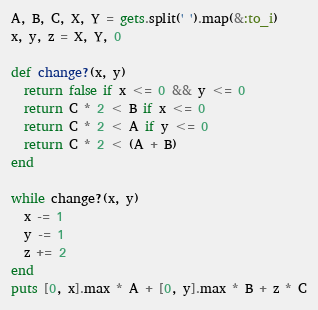Convert code to text. <code><loc_0><loc_0><loc_500><loc_500><_Ruby_>A, B, C, X, Y = gets.split(' ').map(&:to_i)
x, y, z = X, Y, 0

def change?(x, y)
  return false if x <= 0 && y <= 0
  return C * 2 < B if x <= 0
  return C * 2 < A if y <= 0
  return C * 2 < (A + B)
end

while change?(x, y)
  x -= 1
  y -= 1
  z += 2
end
puts [0, x].max * A + [0, y].max * B + z * C
</code> 